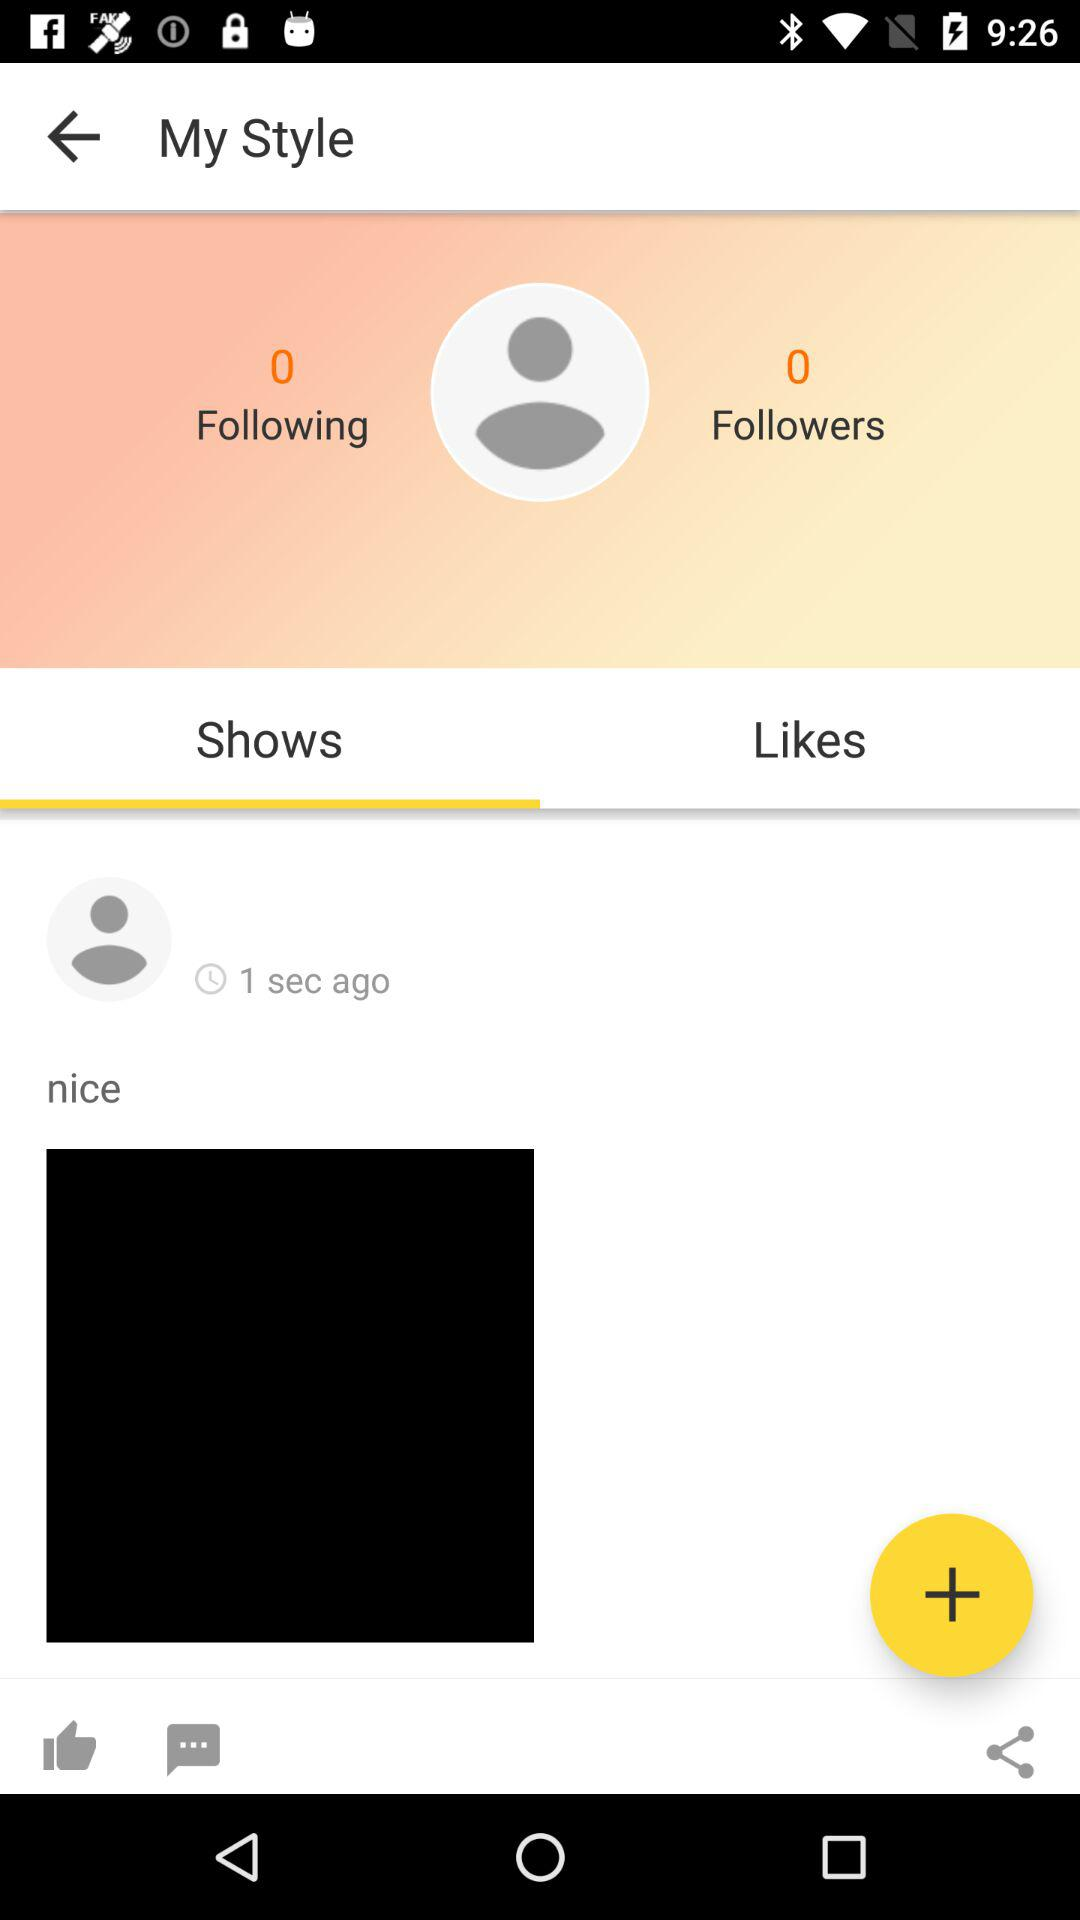What is the number of followers? The number of followers is 0. 